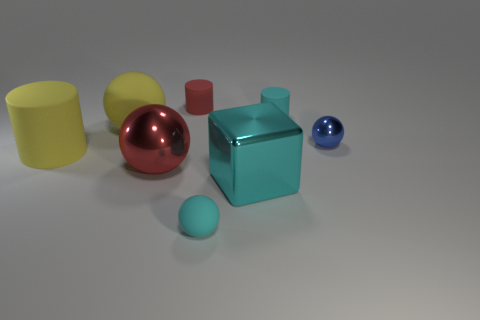Subtract all red balls. How many balls are left? 3 Add 2 large matte balls. How many objects exist? 10 Subtract all cubes. How many objects are left? 7 Subtract 0 brown cubes. How many objects are left? 8 Subtract all large yellow matte cylinders. Subtract all small things. How many objects are left? 3 Add 1 red matte things. How many red matte things are left? 2 Add 7 large blue metal cylinders. How many large blue metal cylinders exist? 7 